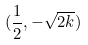<formula> <loc_0><loc_0><loc_500><loc_500>( \frac { 1 } { 2 } , - \sqrt { 2 k } )</formula> 